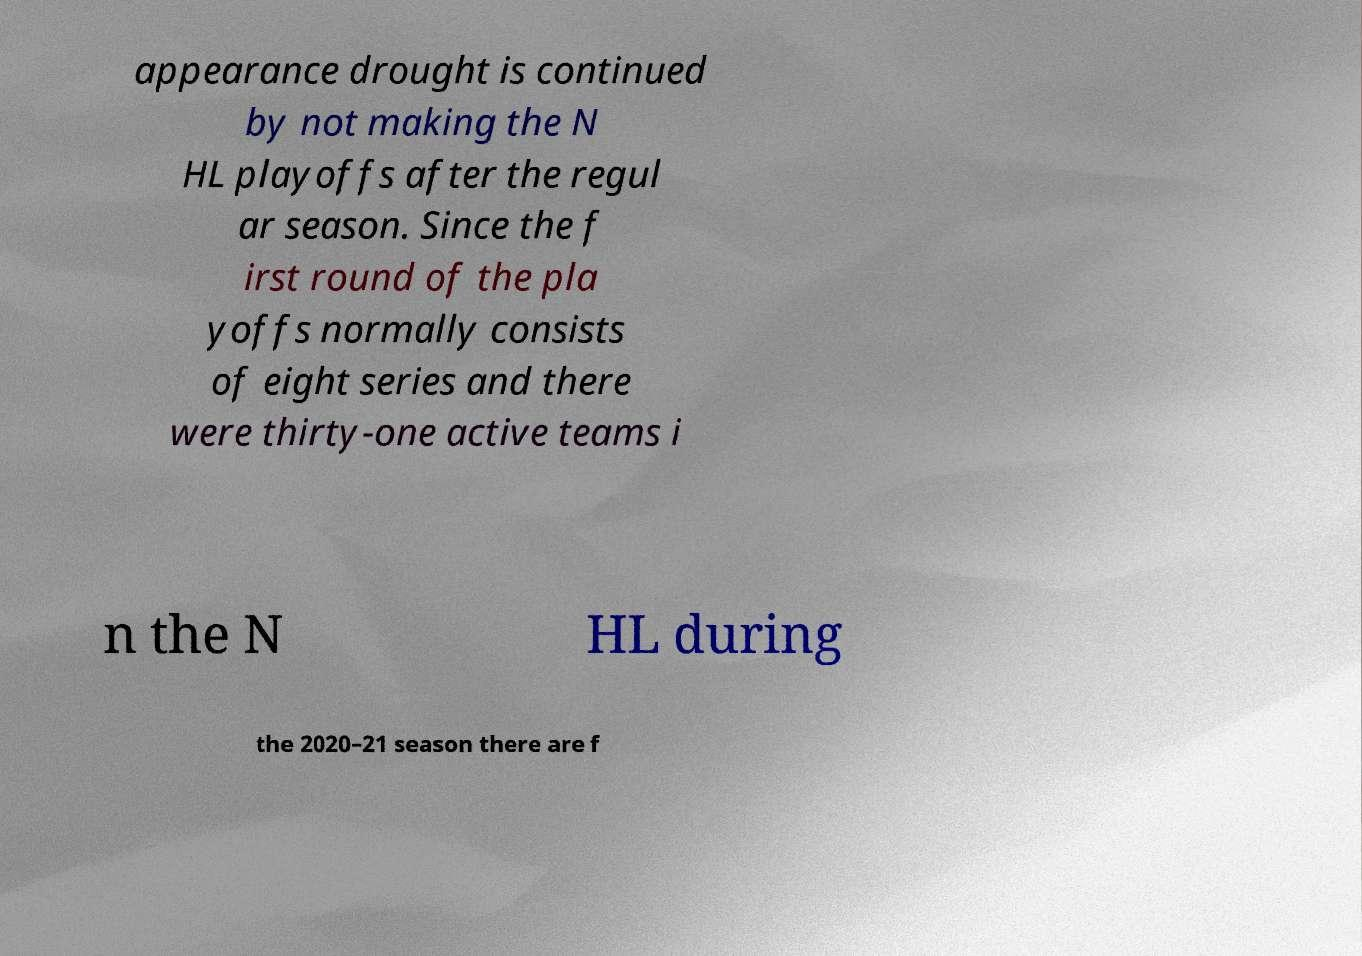Please read and relay the text visible in this image. What does it say? appearance drought is continued by not making the N HL playoffs after the regul ar season. Since the f irst round of the pla yoffs normally consists of eight series and there were thirty-one active teams i n the N HL during the 2020–21 season there are f 